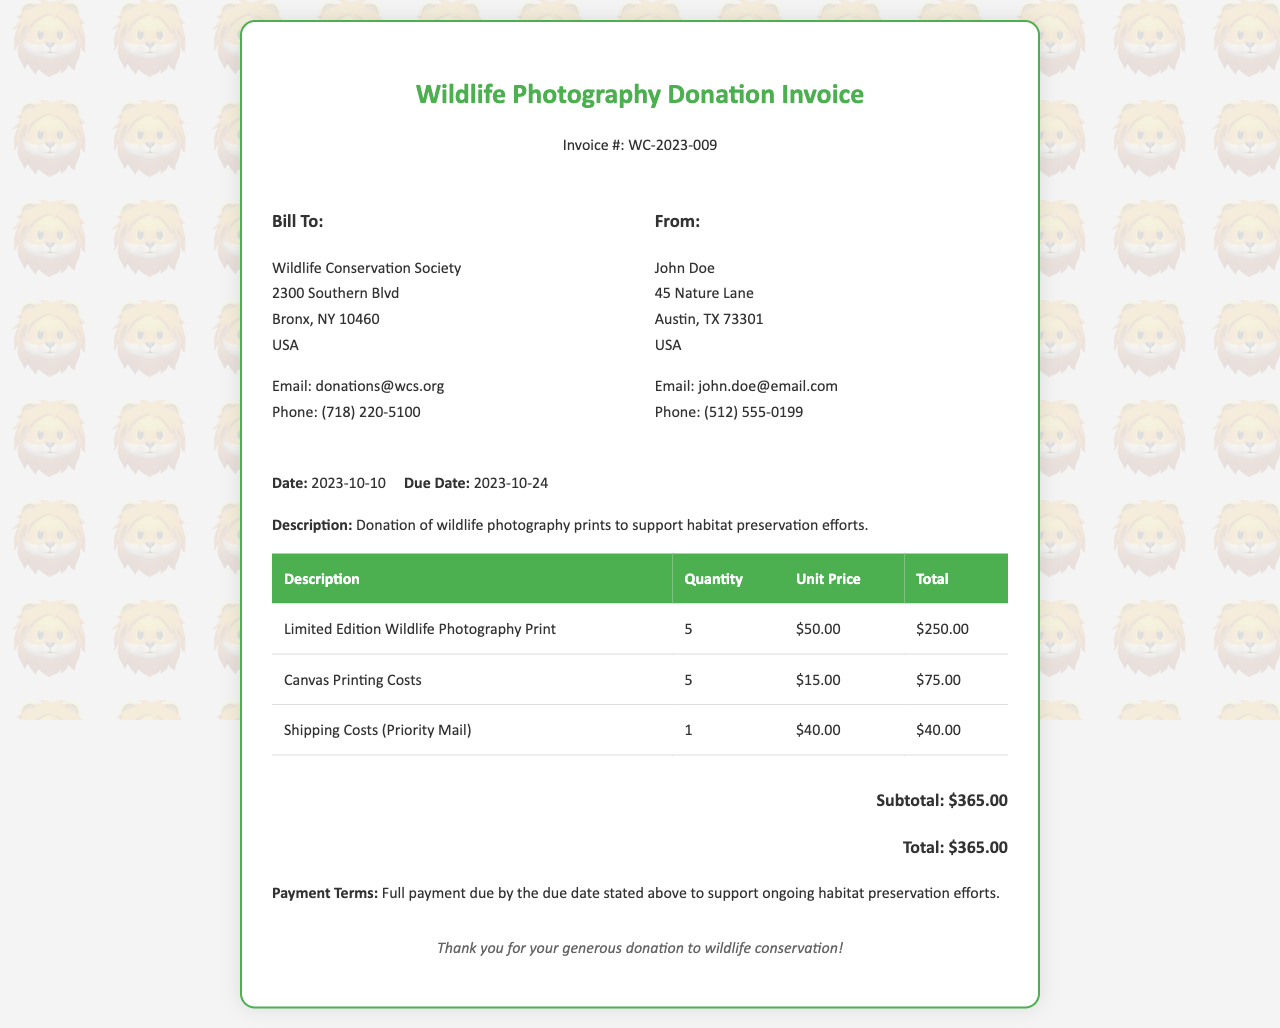what is the invoice number? The invoice number is mentioned at the top of the document as "Invoice #: WC-2023-009."
Answer: WC-2023-009 who is the donation recipient? The recipient of the donation is listed under "Bill To," which is the Wildlife Conservation Society.
Answer: Wildlife Conservation Society what is the total amount due? The total amount due is calculated from the items listed and is stated at the bottom of the invoice as "Total: $365.00."
Answer: $365.00 how many photography prints were donated? The quantity of limited edition wildlife photography prints is specified in the invoice as "5."
Answer: 5 what is the due date for the payment? The due date for the payment is stated in the invoice as "Due Date: 2023-10-24."
Answer: 2023-10-24 what is the subtotal before shipping costs? The subtotal is calculated from the itemized costs before any additional charges, which is "$365.00," as shown in the invoice.
Answer: $365.00 who is the sender of the invoice? The sender's information is located in the "From" section, which lists "John Doe."
Answer: John Doe what is the unit price of canvas printing costs? The unit price for canvas printing costs is specified in the document as "$15.00."
Answer: $15.00 what are the payment terms stated in the invoice? The payment terms are described at the bottom of the invoice, mentioning that full payment is due by the stated due date to support conservation efforts.
Answer: Full payment due by the due date 